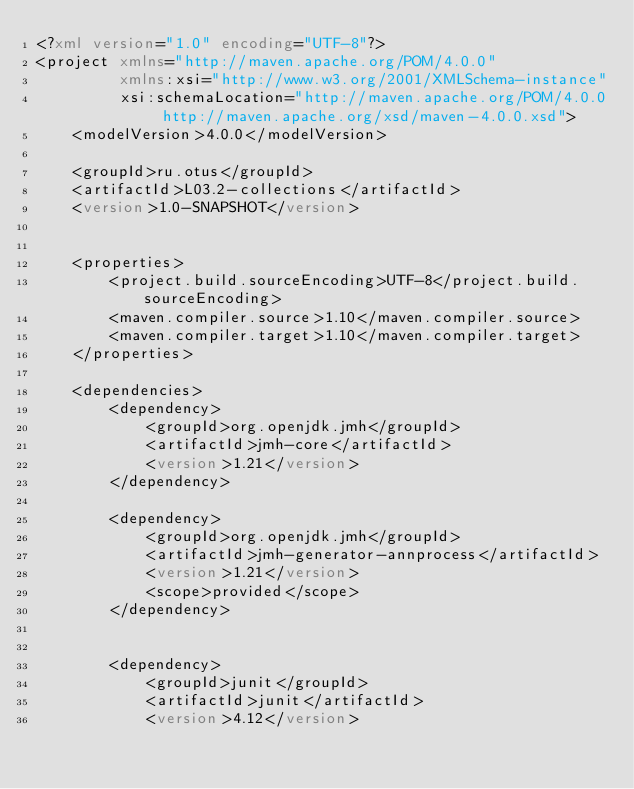<code> <loc_0><loc_0><loc_500><loc_500><_XML_><?xml version="1.0" encoding="UTF-8"?>
<project xmlns="http://maven.apache.org/POM/4.0.0"
         xmlns:xsi="http://www.w3.org/2001/XMLSchema-instance"
         xsi:schemaLocation="http://maven.apache.org/POM/4.0.0 http://maven.apache.org/xsd/maven-4.0.0.xsd">
    <modelVersion>4.0.0</modelVersion>

    <groupId>ru.otus</groupId>
    <artifactId>L03.2-collections</artifactId>
    <version>1.0-SNAPSHOT</version>


    <properties>
        <project.build.sourceEncoding>UTF-8</project.build.sourceEncoding>
        <maven.compiler.source>1.10</maven.compiler.source>
        <maven.compiler.target>1.10</maven.compiler.target>
    </properties>

    <dependencies>
        <dependency>
            <groupId>org.openjdk.jmh</groupId>
            <artifactId>jmh-core</artifactId>
            <version>1.21</version>
        </dependency>

        <dependency>
            <groupId>org.openjdk.jmh</groupId>
            <artifactId>jmh-generator-annprocess</artifactId>
            <version>1.21</version>
            <scope>provided</scope>
        </dependency>


        <dependency>
            <groupId>junit</groupId>
            <artifactId>junit</artifactId>
            <version>4.12</version></code> 